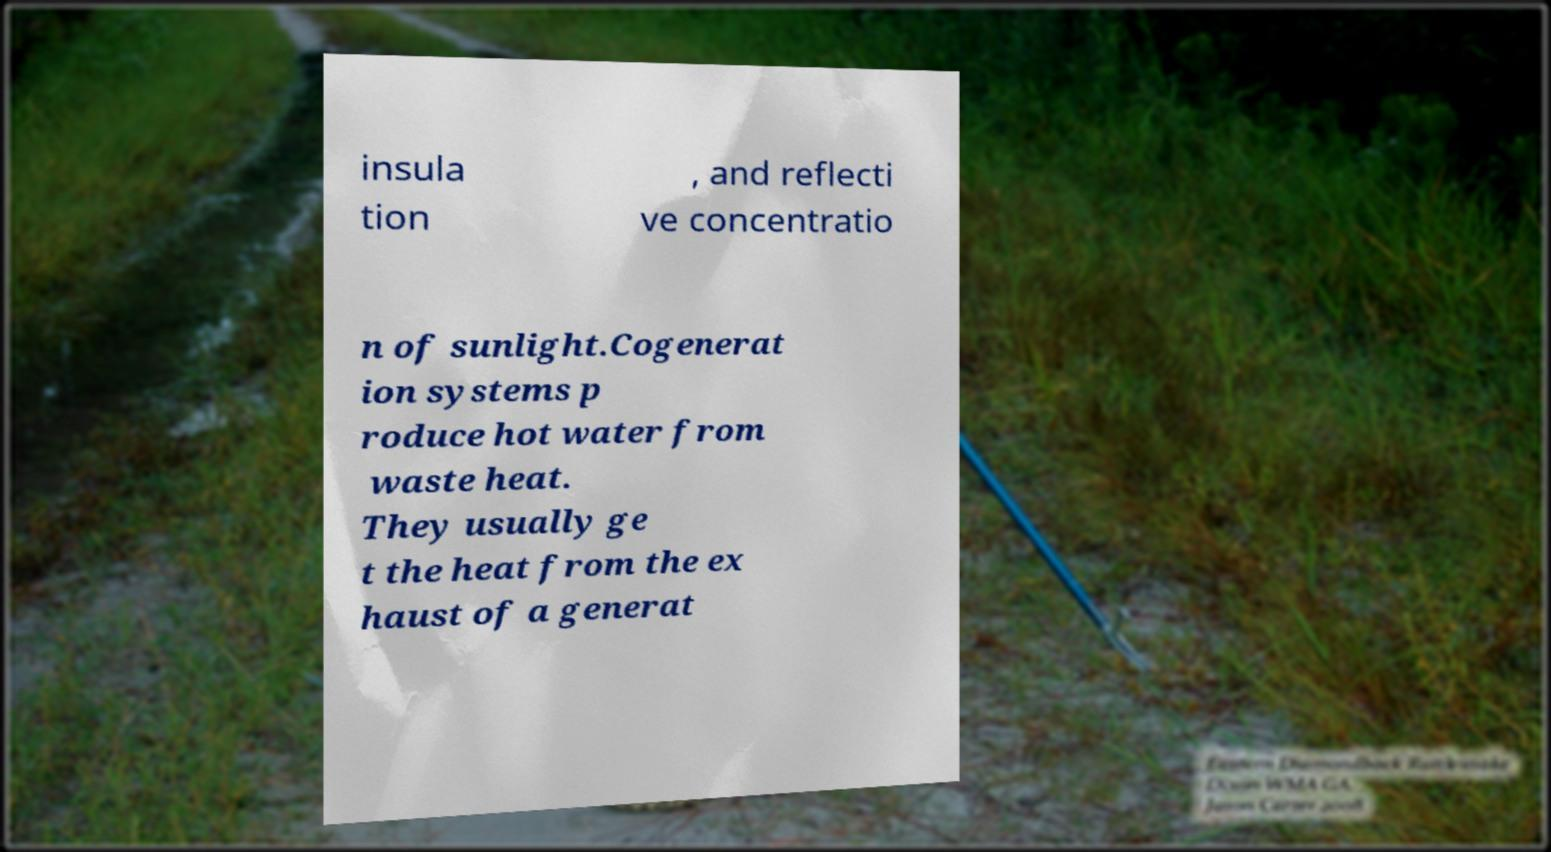Can you read and provide the text displayed in the image?This photo seems to have some interesting text. Can you extract and type it out for me? insula tion , and reflecti ve concentratio n of sunlight.Cogenerat ion systems p roduce hot water from waste heat. They usually ge t the heat from the ex haust of a generat 